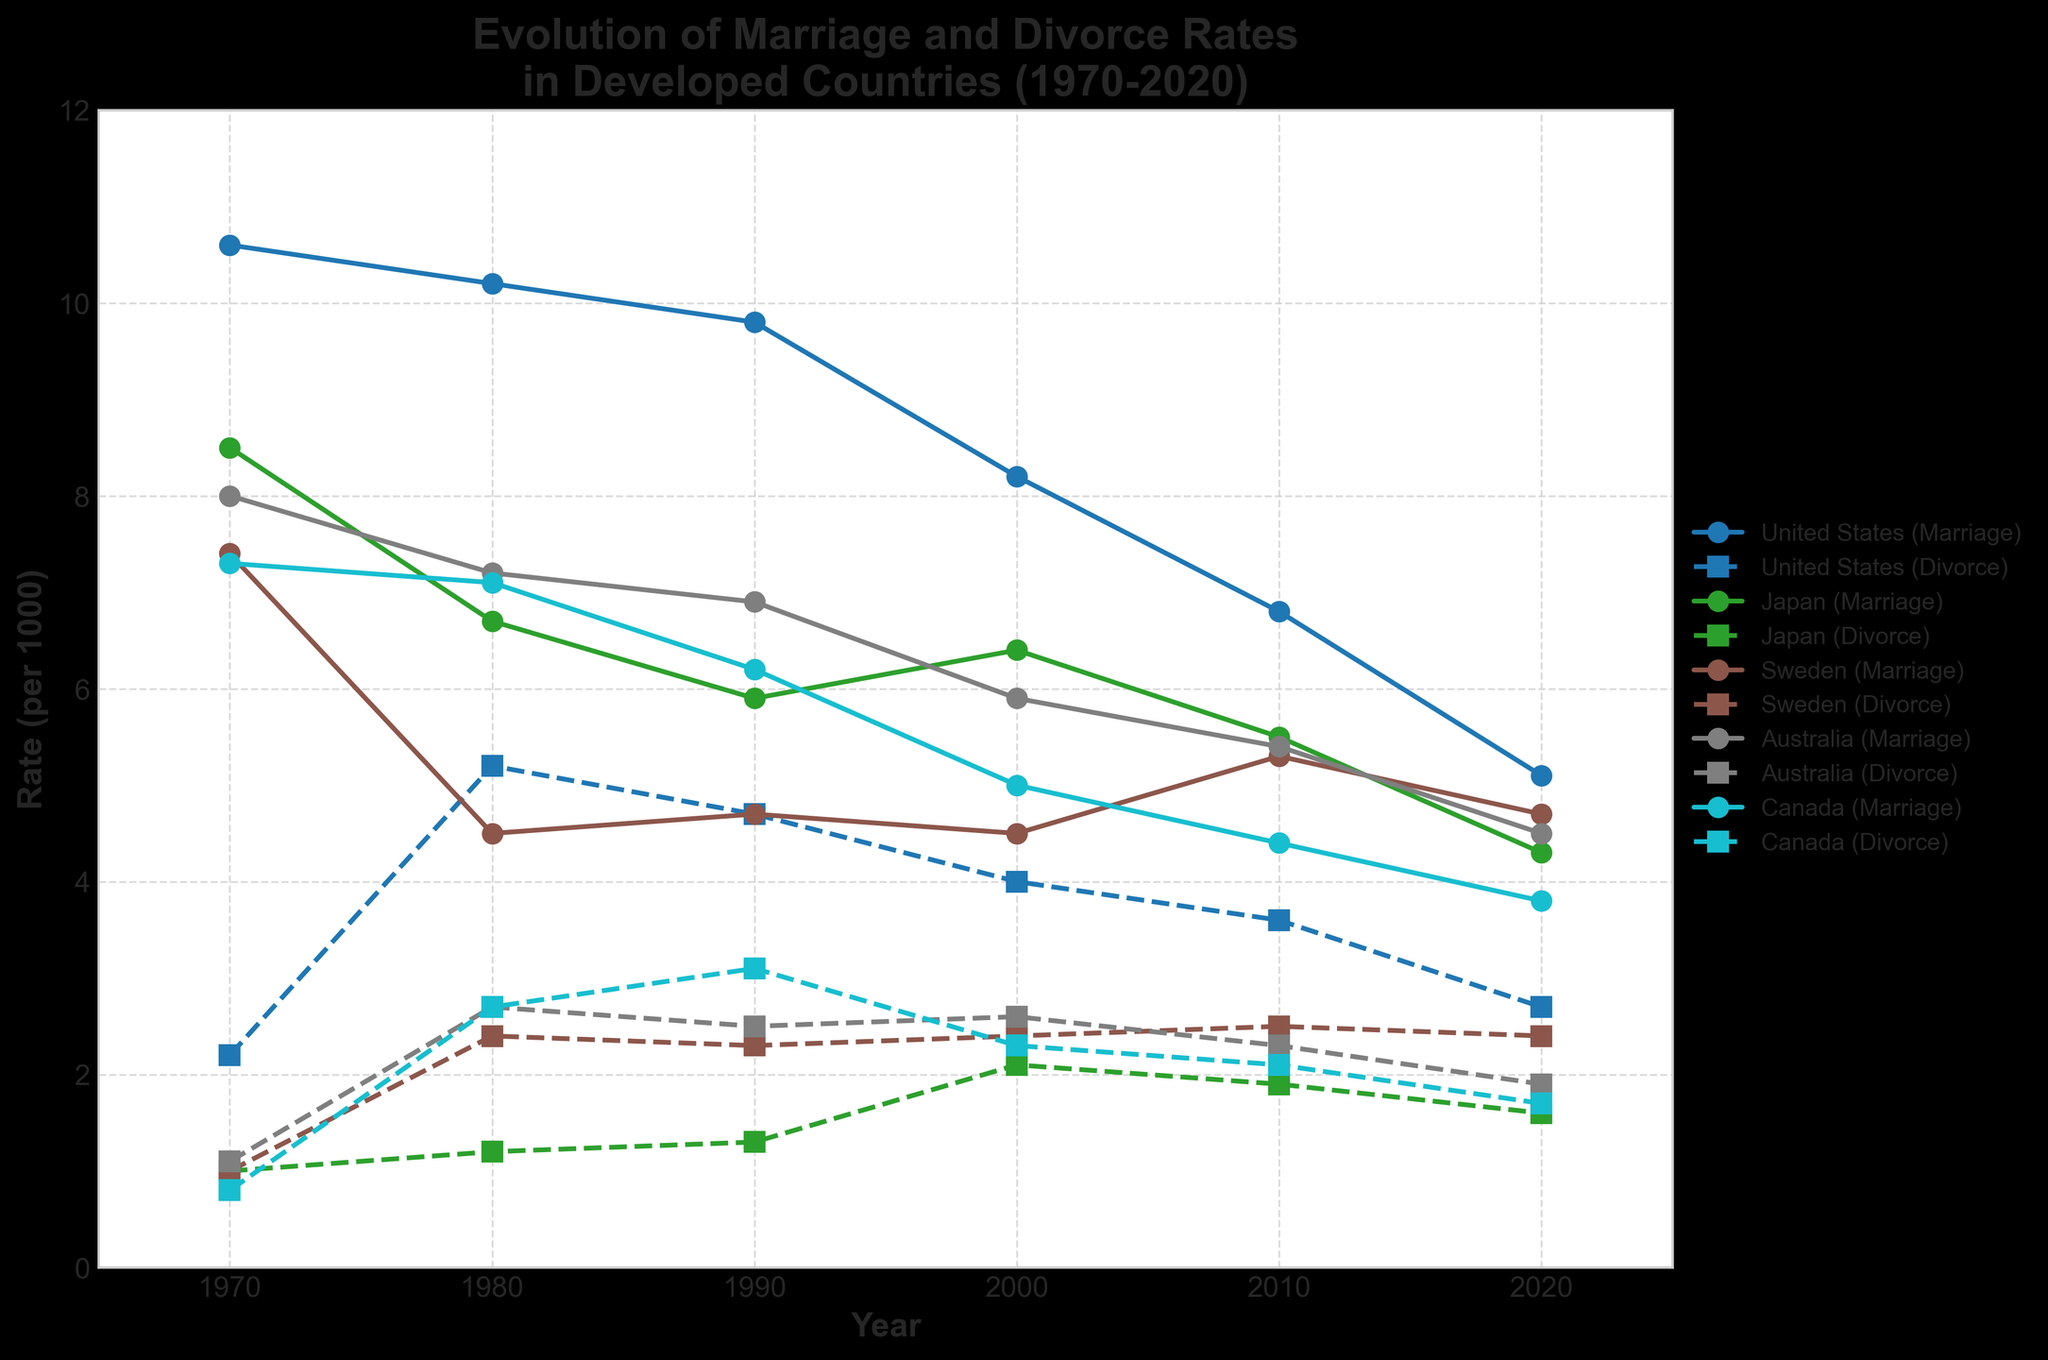what happened to the marriage rate in the United States from 1970 to 2020? Look at the line representing the marriage rate in the United States. It starts at 10.6 in 1970 and declines to 5.1 in 2020. So, it decreased over time.
Answer: It decreased Which country experienced the steepest decline in the marriage rate between 1970 and 2020? Compare the marriage rate lines for all countries. The United States had the highest starting point (10.6 in 1970) and dropped to 5.1 by 2020, which is a decline of 5.5. Other countries had less steep declines.
Answer: United States By how much did the divorce rate in Japan increase from 1970 to 2000? For Japan, calculate the difference between the 2000 divorce rate (2.1) and the 1970 divorce rate (1.0).
Answer: 1.1 Was the marriage rate in Sweden ever higher than the divorce rate in the United States? Check the highest point of the marriage rate in Sweden (7.4) in 1970 and compare it with the lowest divorce rate in the United States (2.2) in 1970.
Answer: Yes Which year had the lowest marriage rate in Canada? Look at the marriage rate line for Canada and find the lowest point, which is in 2020 (3.8).
Answer: 2020 In which country did the divorce rate remain the most stable between 1980 and 2020? Compare the fluctuations of divorce rate lines. Sweden's line appears most stable with 2.4 in 1980 and 2.4 in 2020.
Answer: Sweden What is the difference in the divorce rate between the United States and Australia in 2020? Subtract Australia's divorce rate (1.9) from the United States' divorce rate (2.7) in 2020.
Answer: 0.8 During which decade did the United States experience the largest increase in divorce rate? Compare the increase in divorce rate in each decade for the United States. The largest increase is from 1980 (5.2) to 1970 (2.2), which is 3.0.
Answer: 1970-1980 